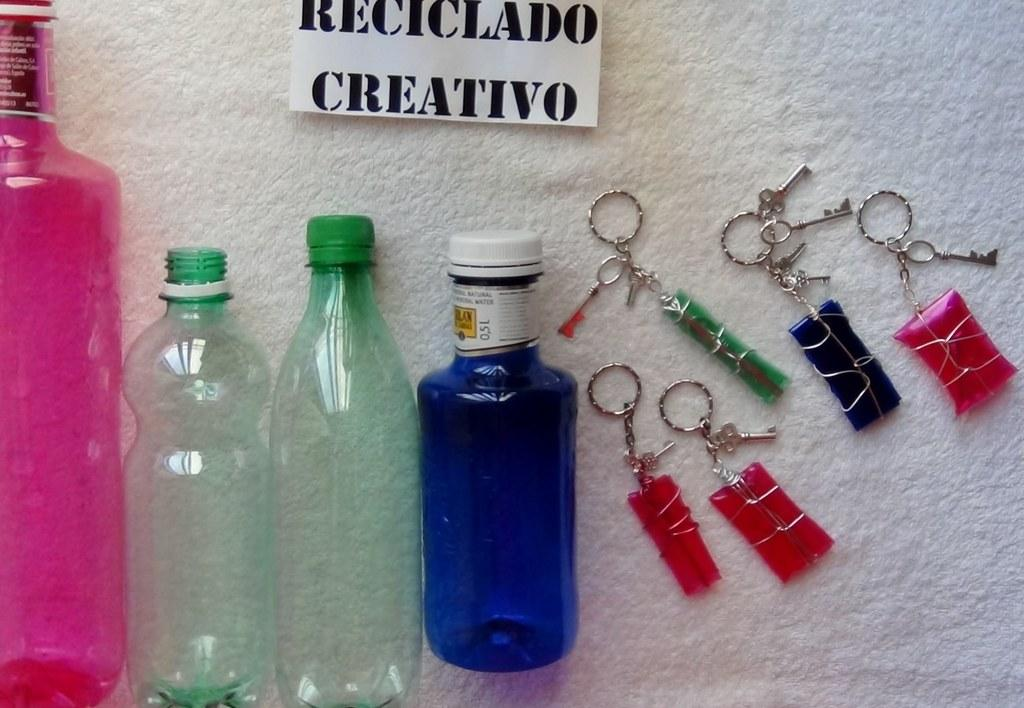What color is the bottle that stands out in the image? There is a pink bottle in the image. How many green bottles are in the image? There are two green bottles in the image. What color is the third bottle? There is a blue bottle in the image. What is the color of the surface on which the bottles are placed? The bottles are on a white surface. What other objects can be seen in the image besides the bottles? There are keys and a name board in the image. What type of observation can be made about the flight of the wheel in the image? There is no wheel or flight present in the image. 